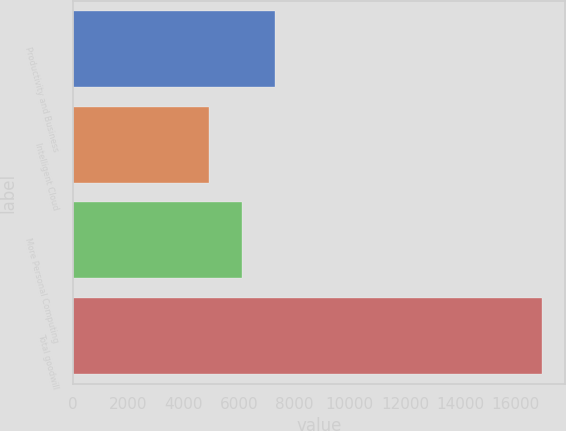Convert chart to OTSL. <chart><loc_0><loc_0><loc_500><loc_500><bar_chart><fcel>Productivity and Business<fcel>Intelligent Cloud<fcel>More Personal Computing<fcel>Total goodwill<nl><fcel>7321.4<fcel>4917<fcel>6119.2<fcel>16939<nl></chart> 